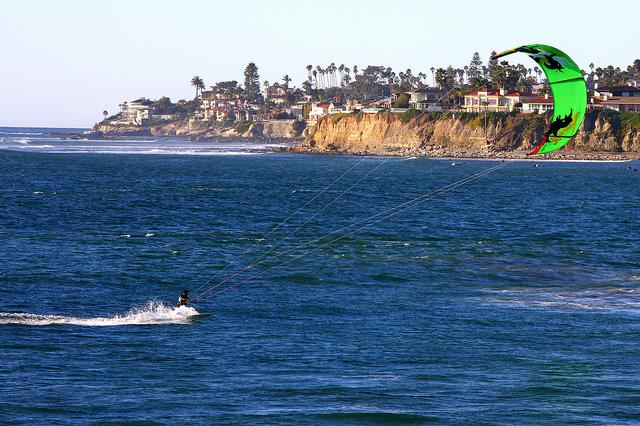What other color is prominent on the kite besides green?
Concise answer only. Black. What activity is this person doing?
Be succinct. Parasailing. What color is the kite?
Be succinct. Green. 